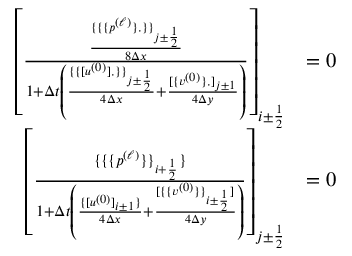<formula> <loc_0><loc_0><loc_500><loc_500>\begin{array} { r l } { \left [ \frac { \frac { \{ \{ \{ p ^ { ( \ell ) } \} _ { \cdot } \} \} _ { j \pm \frac { 1 } { 2 } } } { 8 \Delta x } } { 1 + \Delta t \left ( \frac { \{ \{ [ u ^ { ( 0 ) } ] _ { \cdot } \} \} _ { j \pm \frac { 1 } { 2 } } } { 4 \Delta x } + \frac { [ \{ v ^ { ( 0 ) } \} _ { \cdot } ] _ { j \pm 1 } } { 4 \Delta y } \right ) } \right ] _ { i \pm \frac { 1 } { 2 } } } & { = 0 } \\ { \left [ \frac { \{ \{ \{ p ^ { ( \ell ) } \} \} _ { i + \frac { 1 } { 2 } } \} } { 1 + \Delta t \left ( \frac { \{ [ u ^ { ( 0 ) } ] _ { i \pm 1 } \} } { 4 \Delta x } + \frac { [ \{ \{ v ^ { ( 0 ) } \} \} _ { i \pm \frac { 1 } { 2 } } ] } { 4 \Delta y } \right ) } \right ] _ { j \pm \frac { 1 } { 2 } } } & { = 0 } \end{array}</formula> 